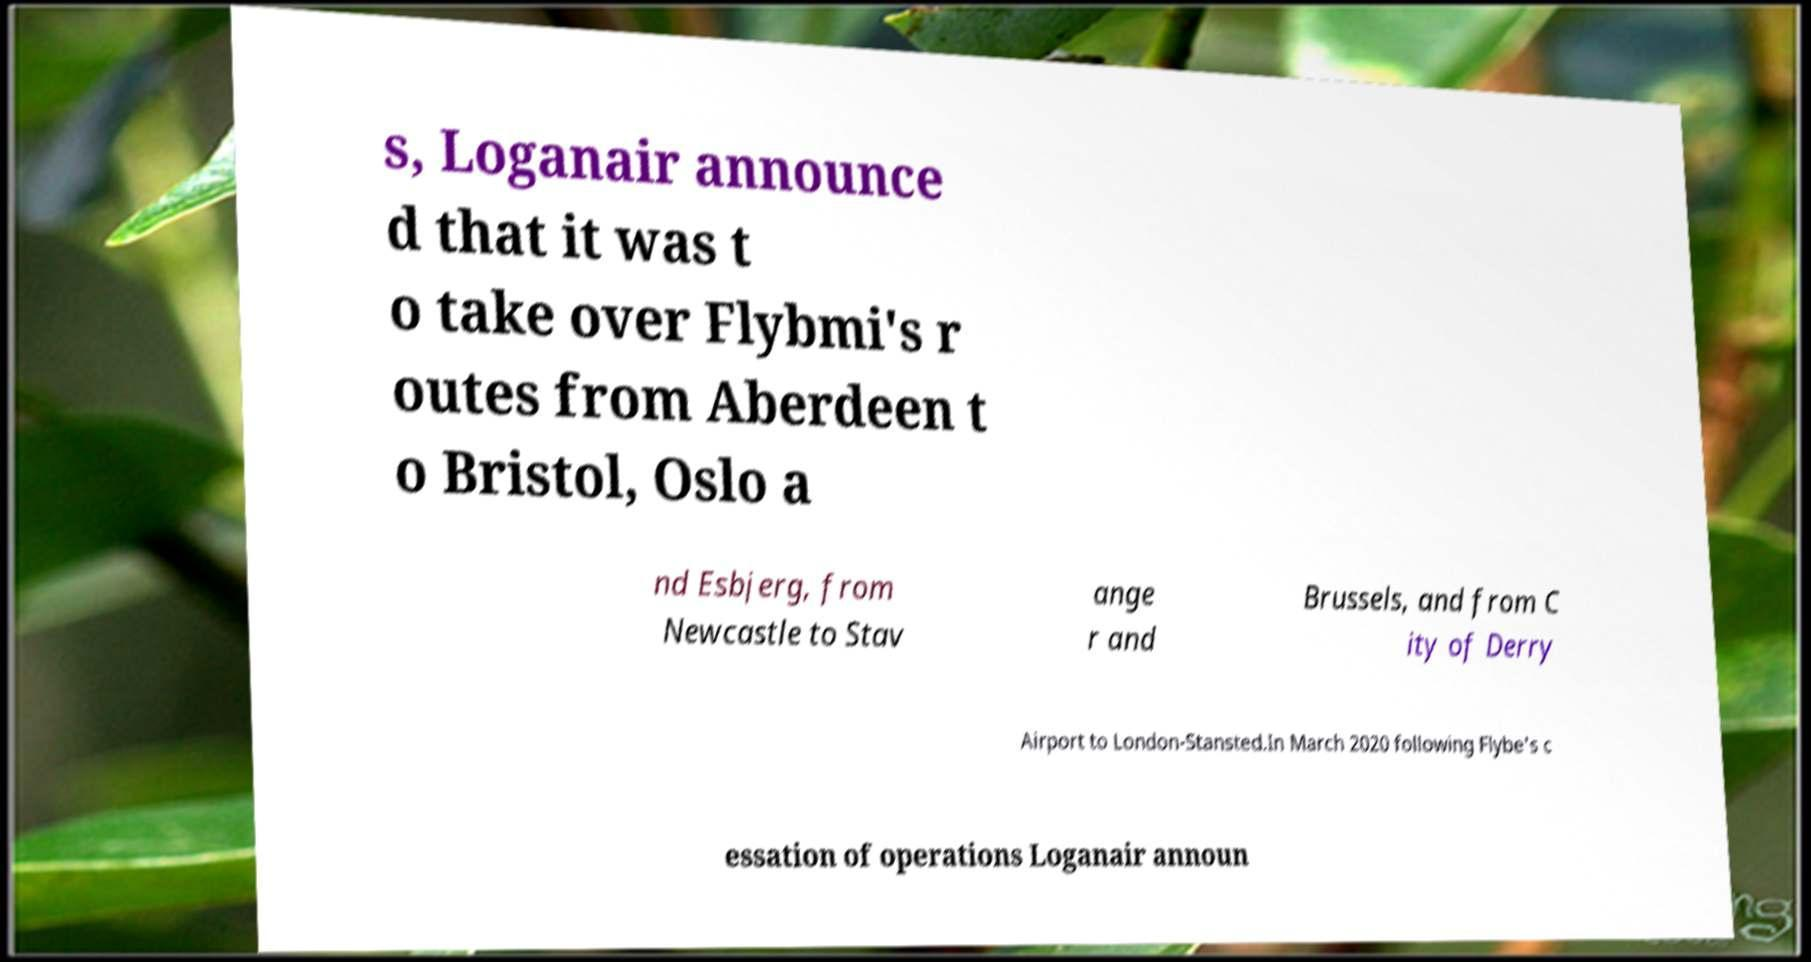For documentation purposes, I need the text within this image transcribed. Could you provide that? s, Loganair announce d that it was t o take over Flybmi's r outes from Aberdeen t o Bristol, Oslo a nd Esbjerg, from Newcastle to Stav ange r and Brussels, and from C ity of Derry Airport to London-Stansted.In March 2020 following Flybe's c essation of operations Loganair announ 